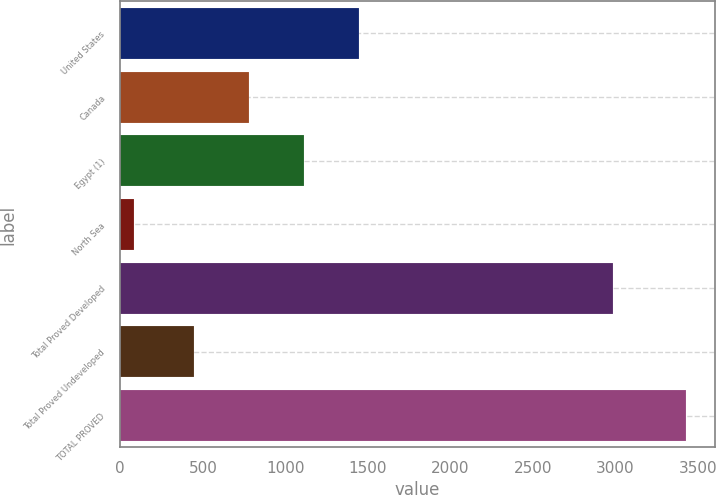<chart> <loc_0><loc_0><loc_500><loc_500><bar_chart><fcel>United States<fcel>Canada<fcel>Egypt (1)<fcel>North Sea<fcel>Total Proved Developed<fcel>Total Proved Undeveloped<fcel>TOTAL PROVED<nl><fcel>1448.2<fcel>779.4<fcel>1113.8<fcel>86<fcel>2985<fcel>445<fcel>3430<nl></chart> 